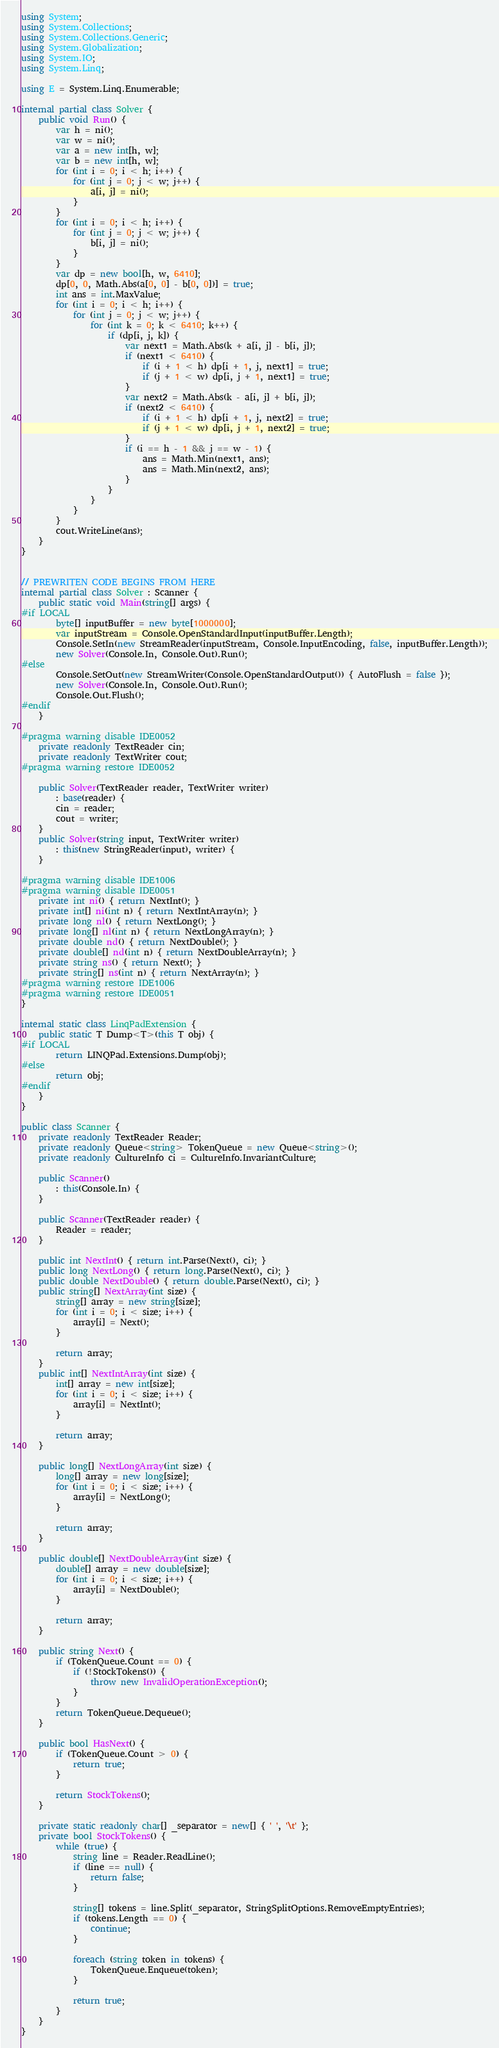Convert code to text. <code><loc_0><loc_0><loc_500><loc_500><_C#_>using System;
using System.Collections;
using System.Collections.Generic;
using System.Globalization;
using System.IO;
using System.Linq;

using E = System.Linq.Enumerable;

internal partial class Solver {
    public void Run() {
        var h = ni();
        var w = ni();
        var a = new int[h, w];
        var b = new int[h, w];
        for (int i = 0; i < h; i++) {
            for (int j = 0; j < w; j++) {
                a[i, j] = ni();
            }
        }
        for (int i = 0; i < h; i++) {
            for (int j = 0; j < w; j++) {
                b[i, j] = ni();
            }
        }
        var dp = new bool[h, w, 6410];
        dp[0, 0, Math.Abs(a[0, 0] - b[0, 0])] = true;
        int ans = int.MaxValue;
        for (int i = 0; i < h; i++) {
            for (int j = 0; j < w; j++) {
                for (int k = 0; k < 6410; k++) {
                    if (dp[i, j, k]) {
                        var next1 = Math.Abs(k + a[i, j] - b[i, j]);
                        if (next1 < 6410) {
                            if (i + 1 < h) dp[i + 1, j, next1] = true;
                            if (j + 1 < w) dp[i, j + 1, next1] = true;
                        }
                        var next2 = Math.Abs(k - a[i, j] + b[i, j]);
                        if (next2 < 6410) {
                            if (i + 1 < h) dp[i + 1, j, next2] = true;
                            if (j + 1 < w) dp[i, j + 1, next2] = true;
                        }
                        if (i == h - 1 && j == w - 1) {
                            ans = Math.Min(next1, ans);
                            ans = Math.Min(next2, ans);
                        }
                    }
                }
            }
        }
        cout.WriteLine(ans);
    }
}


// PREWRITEN CODE BEGINS FROM HERE
internal partial class Solver : Scanner {
    public static void Main(string[] args) {
#if LOCAL
        byte[] inputBuffer = new byte[1000000];
        var inputStream = Console.OpenStandardInput(inputBuffer.Length);
        Console.SetIn(new StreamReader(inputStream, Console.InputEncoding, false, inputBuffer.Length));
        new Solver(Console.In, Console.Out).Run();
#else
        Console.SetOut(new StreamWriter(Console.OpenStandardOutput()) { AutoFlush = false });
        new Solver(Console.In, Console.Out).Run();
        Console.Out.Flush();
#endif
    }

#pragma warning disable IDE0052
    private readonly TextReader cin;
    private readonly TextWriter cout;
#pragma warning restore IDE0052

    public Solver(TextReader reader, TextWriter writer)
        : base(reader) {
        cin = reader;
        cout = writer;
    }
    public Solver(string input, TextWriter writer)
        : this(new StringReader(input), writer) {
    }

#pragma warning disable IDE1006
#pragma warning disable IDE0051
    private int ni() { return NextInt(); }
    private int[] ni(int n) { return NextIntArray(n); }
    private long nl() { return NextLong(); }
    private long[] nl(int n) { return NextLongArray(n); }
    private double nd() { return NextDouble(); }
    private double[] nd(int n) { return NextDoubleArray(n); }
    private string ns() { return Next(); }
    private string[] ns(int n) { return NextArray(n); }
#pragma warning restore IDE1006
#pragma warning restore IDE0051
}

internal static class LinqPadExtension {
    public static T Dump<T>(this T obj) {
#if LOCAL
        return LINQPad.Extensions.Dump(obj);
#else
        return obj;
#endif
    }
}

public class Scanner {
    private readonly TextReader Reader;
    private readonly Queue<string> TokenQueue = new Queue<string>();
    private readonly CultureInfo ci = CultureInfo.InvariantCulture;

    public Scanner()
        : this(Console.In) {
    }

    public Scanner(TextReader reader) {
        Reader = reader;
    }

    public int NextInt() { return int.Parse(Next(), ci); }
    public long NextLong() { return long.Parse(Next(), ci); }
    public double NextDouble() { return double.Parse(Next(), ci); }
    public string[] NextArray(int size) {
        string[] array = new string[size];
        for (int i = 0; i < size; i++) {
            array[i] = Next();
        }

        return array;
    }
    public int[] NextIntArray(int size) {
        int[] array = new int[size];
        for (int i = 0; i < size; i++) {
            array[i] = NextInt();
        }

        return array;
    }

    public long[] NextLongArray(int size) {
        long[] array = new long[size];
        for (int i = 0; i < size; i++) {
            array[i] = NextLong();
        }

        return array;
    }

    public double[] NextDoubleArray(int size) {
        double[] array = new double[size];
        for (int i = 0; i < size; i++) {
            array[i] = NextDouble();
        }

        return array;
    }

    public string Next() {
        if (TokenQueue.Count == 0) {
            if (!StockTokens()) {
                throw new InvalidOperationException();
            }
        }
        return TokenQueue.Dequeue();
    }

    public bool HasNext() {
        if (TokenQueue.Count > 0) {
            return true;
        }

        return StockTokens();
    }

    private static readonly char[] _separator = new[] { ' ', '\t' };
    private bool StockTokens() {
        while (true) {
            string line = Reader.ReadLine();
            if (line == null) {
                return false;
            }

            string[] tokens = line.Split(_separator, StringSplitOptions.RemoveEmptyEntries);
            if (tokens.Length == 0) {
                continue;
            }

            foreach (string token in tokens) {
                TokenQueue.Enqueue(token);
            }

            return true;
        }
    }
}
</code> 